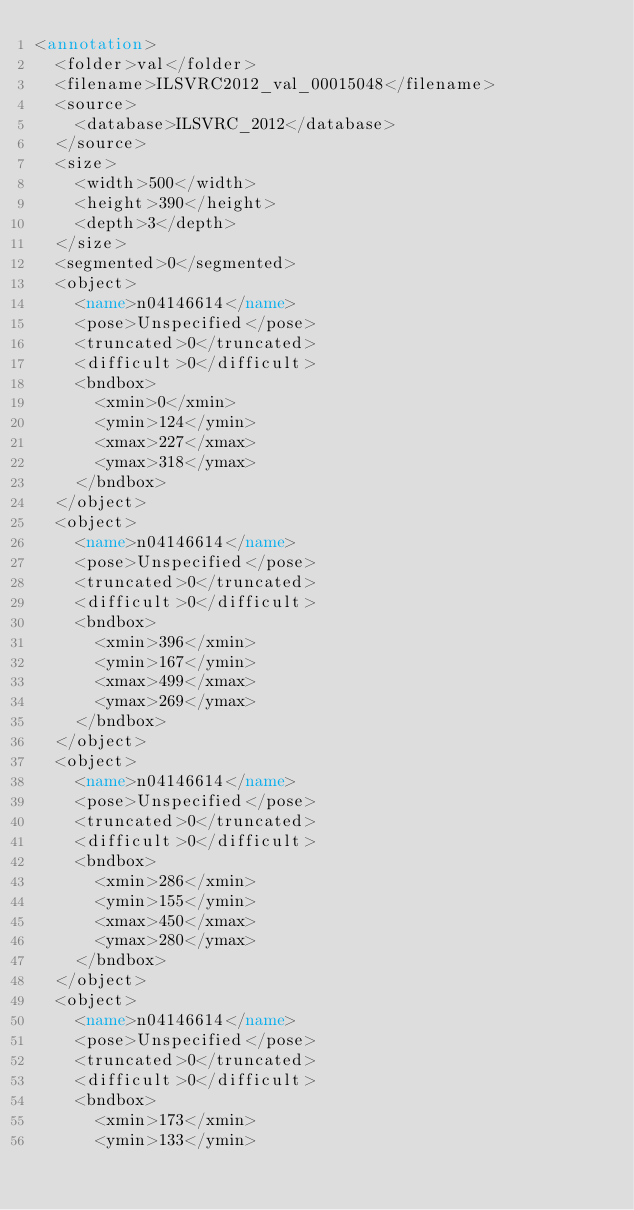Convert code to text. <code><loc_0><loc_0><loc_500><loc_500><_XML_><annotation>
	<folder>val</folder>
	<filename>ILSVRC2012_val_00015048</filename>
	<source>
		<database>ILSVRC_2012</database>
	</source>
	<size>
		<width>500</width>
		<height>390</height>
		<depth>3</depth>
	</size>
	<segmented>0</segmented>
	<object>
		<name>n04146614</name>
		<pose>Unspecified</pose>
		<truncated>0</truncated>
		<difficult>0</difficult>
		<bndbox>
			<xmin>0</xmin>
			<ymin>124</ymin>
			<xmax>227</xmax>
			<ymax>318</ymax>
		</bndbox>
	</object>
	<object>
		<name>n04146614</name>
		<pose>Unspecified</pose>
		<truncated>0</truncated>
		<difficult>0</difficult>
		<bndbox>
			<xmin>396</xmin>
			<ymin>167</ymin>
			<xmax>499</xmax>
			<ymax>269</ymax>
		</bndbox>
	</object>
	<object>
		<name>n04146614</name>
		<pose>Unspecified</pose>
		<truncated>0</truncated>
		<difficult>0</difficult>
		<bndbox>
			<xmin>286</xmin>
			<ymin>155</ymin>
			<xmax>450</xmax>
			<ymax>280</ymax>
		</bndbox>
	</object>
	<object>
		<name>n04146614</name>
		<pose>Unspecified</pose>
		<truncated>0</truncated>
		<difficult>0</difficult>
		<bndbox>
			<xmin>173</xmin>
			<ymin>133</ymin></code> 